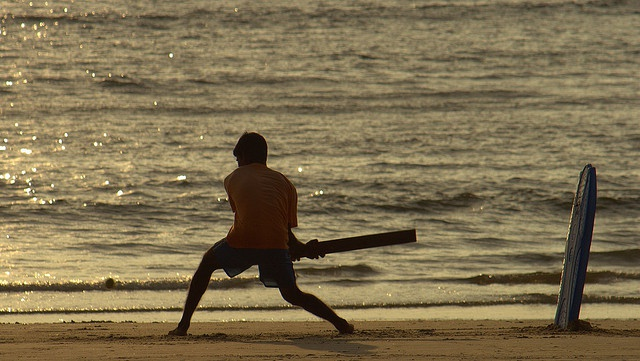Describe the objects in this image and their specific colors. I can see people in tan, black, maroon, and olive tones and surfboard in tan, black, and gray tones in this image. 